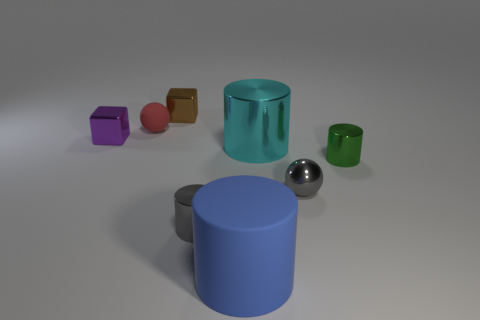What shape is the other object that is the same material as the small red thing?
Provide a short and direct response. Cylinder. Is there any other thing that is the same color as the large metal cylinder?
Provide a succinct answer. No. What is the material of the ball that is on the left side of the gray object that is on the left side of the large blue matte thing?
Your response must be concise. Rubber. Is there a large cyan metallic object of the same shape as the green object?
Keep it short and to the point. Yes. How many other objects are there of the same shape as the brown object?
Give a very brief answer. 1. There is a tiny metal thing that is right of the blue object and behind the small metal ball; what is its shape?
Offer a very short reply. Cylinder. How big is the rubber object to the right of the brown cube?
Offer a terse response. Large. Is the purple metallic block the same size as the green cylinder?
Make the answer very short. Yes. Is the number of matte things in front of the small green object less than the number of things that are in front of the small purple cube?
Your response must be concise. Yes. What is the size of the cylinder that is both right of the gray cylinder and left of the cyan object?
Your answer should be compact. Large. 